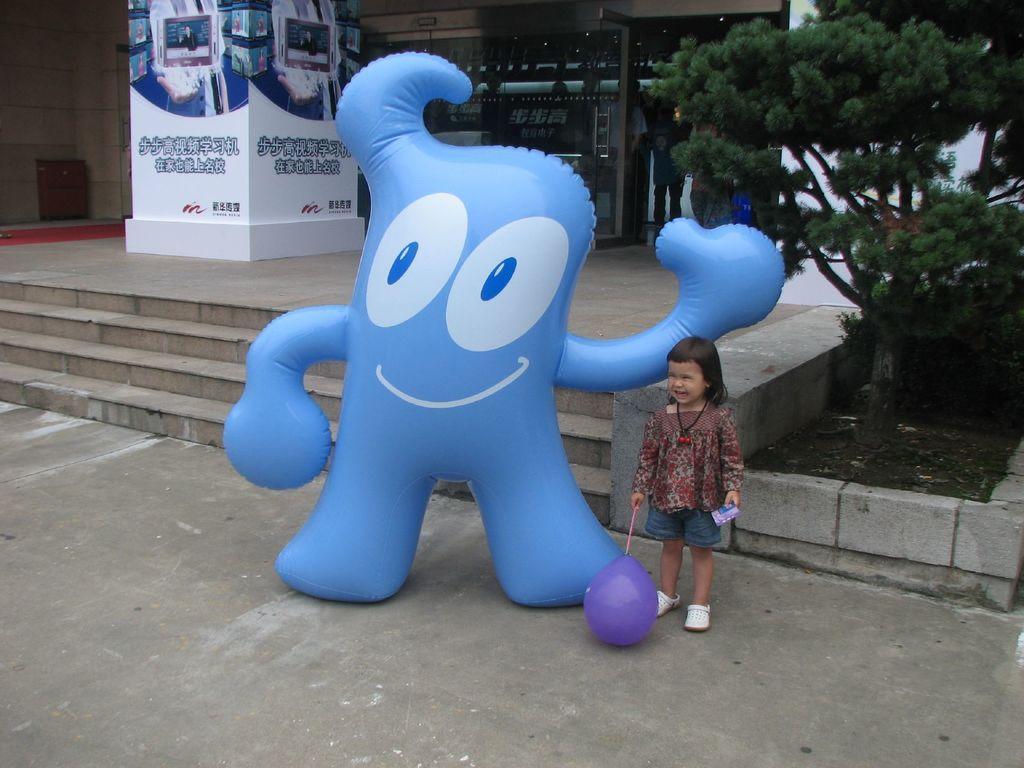Describe this image in one or two sentences. In this image, we can see a kid holding some objects. We can see a blue colored balloon. We can see some stairs. There are a few trees. We can see a person. We can see the wall and a white colored object. We can see the door with some text printed. 